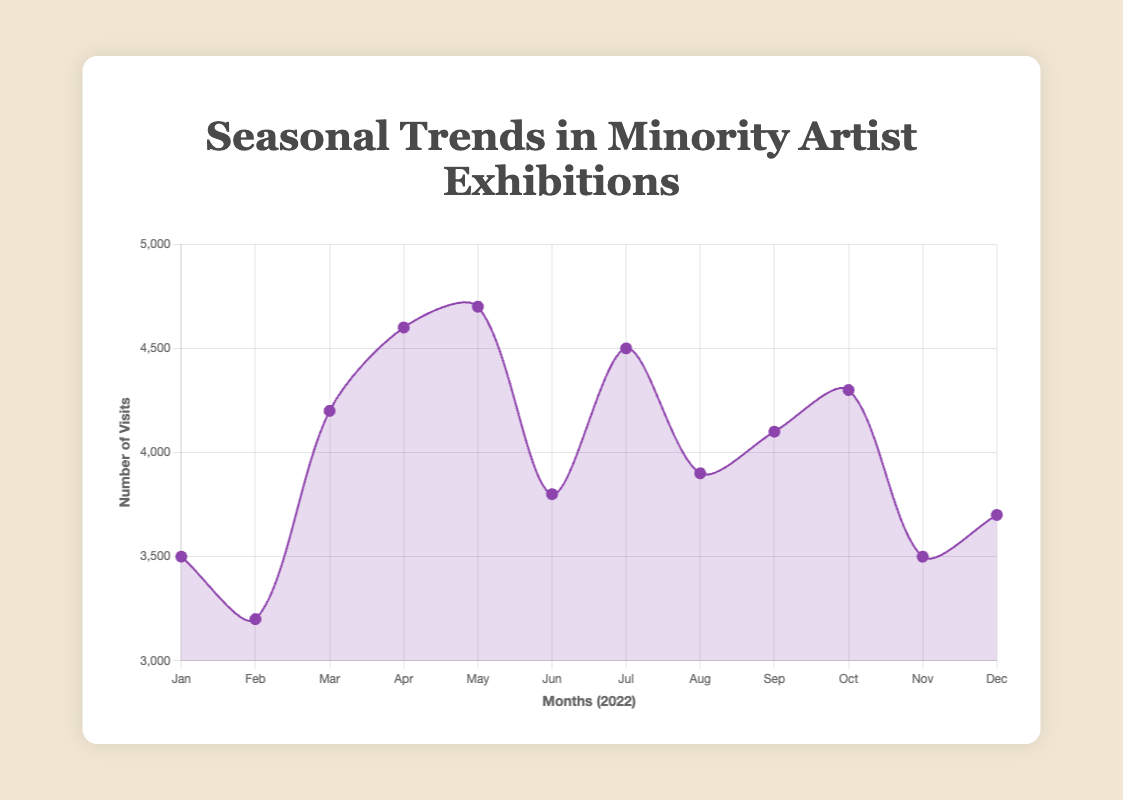Which month had the highest number of visits to exhibitions? The highest point on the line plot will indicate the month with the highest number of visits. According to the data, May had the peak with 4700 visits.
Answer: May Compare the number of visits in February and June. Which month had more visits and by how much? By looking at the y-axis values for February and June, we can see that February had 3200 visits and June had 3800 visits. June had 600 more visits than February.
Answer: June, by 600 visits What is the average number of visits across all months? Summing the visits for each month: 3500 + 3200 + 4200 + 4600 + 4700 + 3800 + 4500 + 3900 + 4100 + 4300 + 3500 + 3700 = 48000. The average is 48000/12.
Answer: 4000 Which artist's exhibition had the lowest number of visits, and in which month did it occur? The lowest point on the line plot indicates the lowest number of visits. February had the lowest with 3200 visits, and the exhibition was "Cultural Memory" by Kara Walker.
Answer: Kara Walker ("Cultural Memory"), February What is the difference in the number of visits between the most and least visited exhibitions? Identify the peak and trough in the line plot: the most visited month (May, 4700 visits) and the least visited month (February, 3200 visits). The difference is 4700 - 3200.
Answer: 1500 How many months had more than 4000 visits to exhibitions? Observing the line plot, the months exceeding the 4000 visit mark are March, April, May, July, September, and October. That's 6 months in total.
Answer: 6 months Which exhibition had a higher number of visits: "Portraits of Resilience" or "Narratives in Motion"? "Portraits of Resilience" (January) had 3500 visits, while "Narratives in Motion" (July) had 4500 visits.
Answer: Narratives in Motion What is the total number of visits in the second half of the year (July to December)? Sum the visits from July to December: 4500 + 3900 + 4100 + 4300 + 3500 + 3700 = 24000.
Answer: 24000 Compare the total number of visits in the first half of the year (January to June) to the second half (July to December). Which half had more visits, and by how much? Calculate the sum for each half: January to June = 3500 + 3200 + 4200 + 4600 + 4700 + 3800 = 24000; July to December = 4500 + 3900 + 4100 + 4300 + 3500 + 3700 = 24000. Since both sums are equal, neither half had more visits.
Answer: Both are equal at 24000 